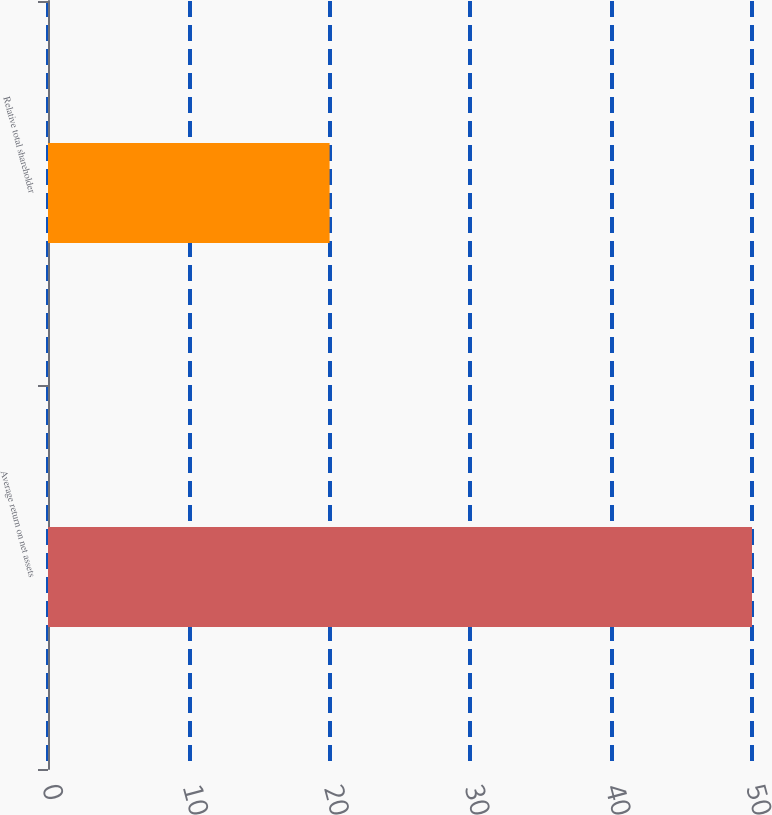Convert chart to OTSL. <chart><loc_0><loc_0><loc_500><loc_500><bar_chart><fcel>Average return on net assets<fcel>Relative total shareholder<nl><fcel>50<fcel>20<nl></chart> 